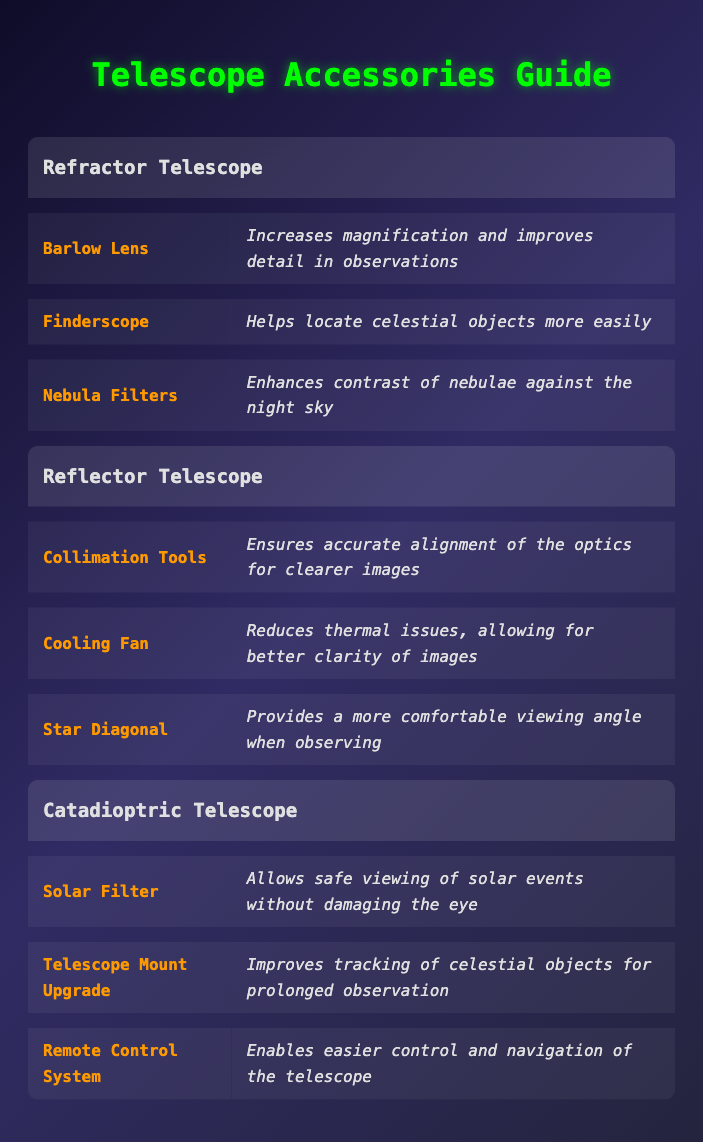What impact does a Barlow Lens have on stargazing? The table states that a Barlow Lens "increases magnification and improves detail in observations," suggesting it allows for a closer view of celestial objects.
Answer: Increases magnification and improves detail Which telescope accessory enhances contrast of nebulae against the night sky? Referring to the table, Nebula Filters are specifically mentioned to enhance contrast of nebulae.
Answer: Nebula Filters Is a Cooling Fan listed as an accessory for Refractor Telescopes? The table shows that a Cooling Fan is listed under Reflector Telescopes, not Refractor Telescopes, indicating it is not an accessory for them.
Answer: No How many accessories are there for Catadioptric Telescopes? According to the table, there are three accessories listed: Solar Filter, Telescope Mount Upgrade, and Remote Control System for Catadioptric Telescopes.
Answer: Three accessories Which telescope accessory provides a more comfortable viewing angle? The table specifies that the Star Diagonal is the accessory that provides a more comfortable viewing angle for Reflector Telescopes.
Answer: Star Diagonal Do all the types of telescopes have a filter accessory? Reviewing the table, only the Refractor and Catadioptric Telescopes have filter accessories (Nebula Filters and Solar Filter respectively), while the Reflector Telescope does not have one.
Answer: No What is the main purpose of Colimation Tools? The table details that Collimation Tools "ensure accurate alignment of the optics for clearer images," indicating their role in maintaining image quality in Reflector Telescopes.
Answer: To ensure accurate alignment of optics If a user has a Reflector Telescope, which accessory would be most beneficial for reducing thermal issues? The table shows that a Cooling Fan is specifically listed as an accessory for Reflector Telescopes to reduce thermal issues, thus benefiting clarity.
Answer: Cooling Fan Which telescope type has an accessory specifically for safe solar viewing? The table indicates that the Solar Filter is an accessory of the Catadioptric Telescope which is meant for safe viewing of solar events.
Answer: Catadioptric Telescope 